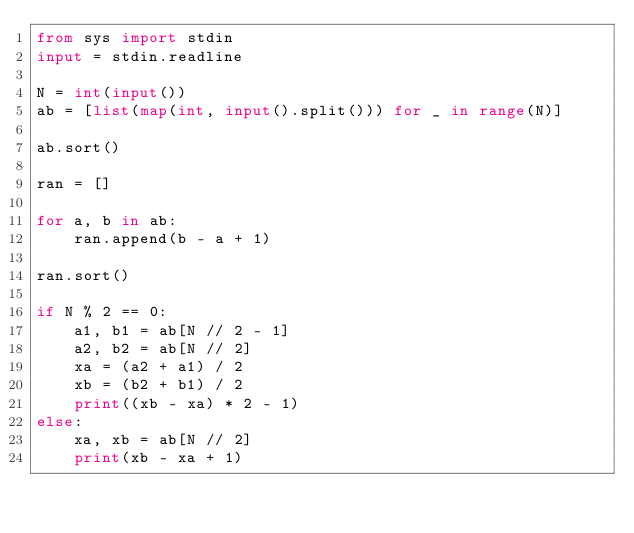Convert code to text. <code><loc_0><loc_0><loc_500><loc_500><_Python_>from sys import stdin
input = stdin.readline

N = int(input())
ab = [list(map(int, input().split())) for _ in range(N)]

ab.sort()

ran = []

for a, b in ab:
    ran.append(b - a + 1)

ran.sort()

if N % 2 == 0:
    a1, b1 = ab[N // 2 - 1]
    a2, b2 = ab[N // 2]
    xa = (a2 + a1) / 2
    xb = (b2 + b1) / 2
    print((xb - xa) * 2 - 1)
else:
    xa, xb = ab[N // 2]
    print(xb - xa + 1)
</code> 